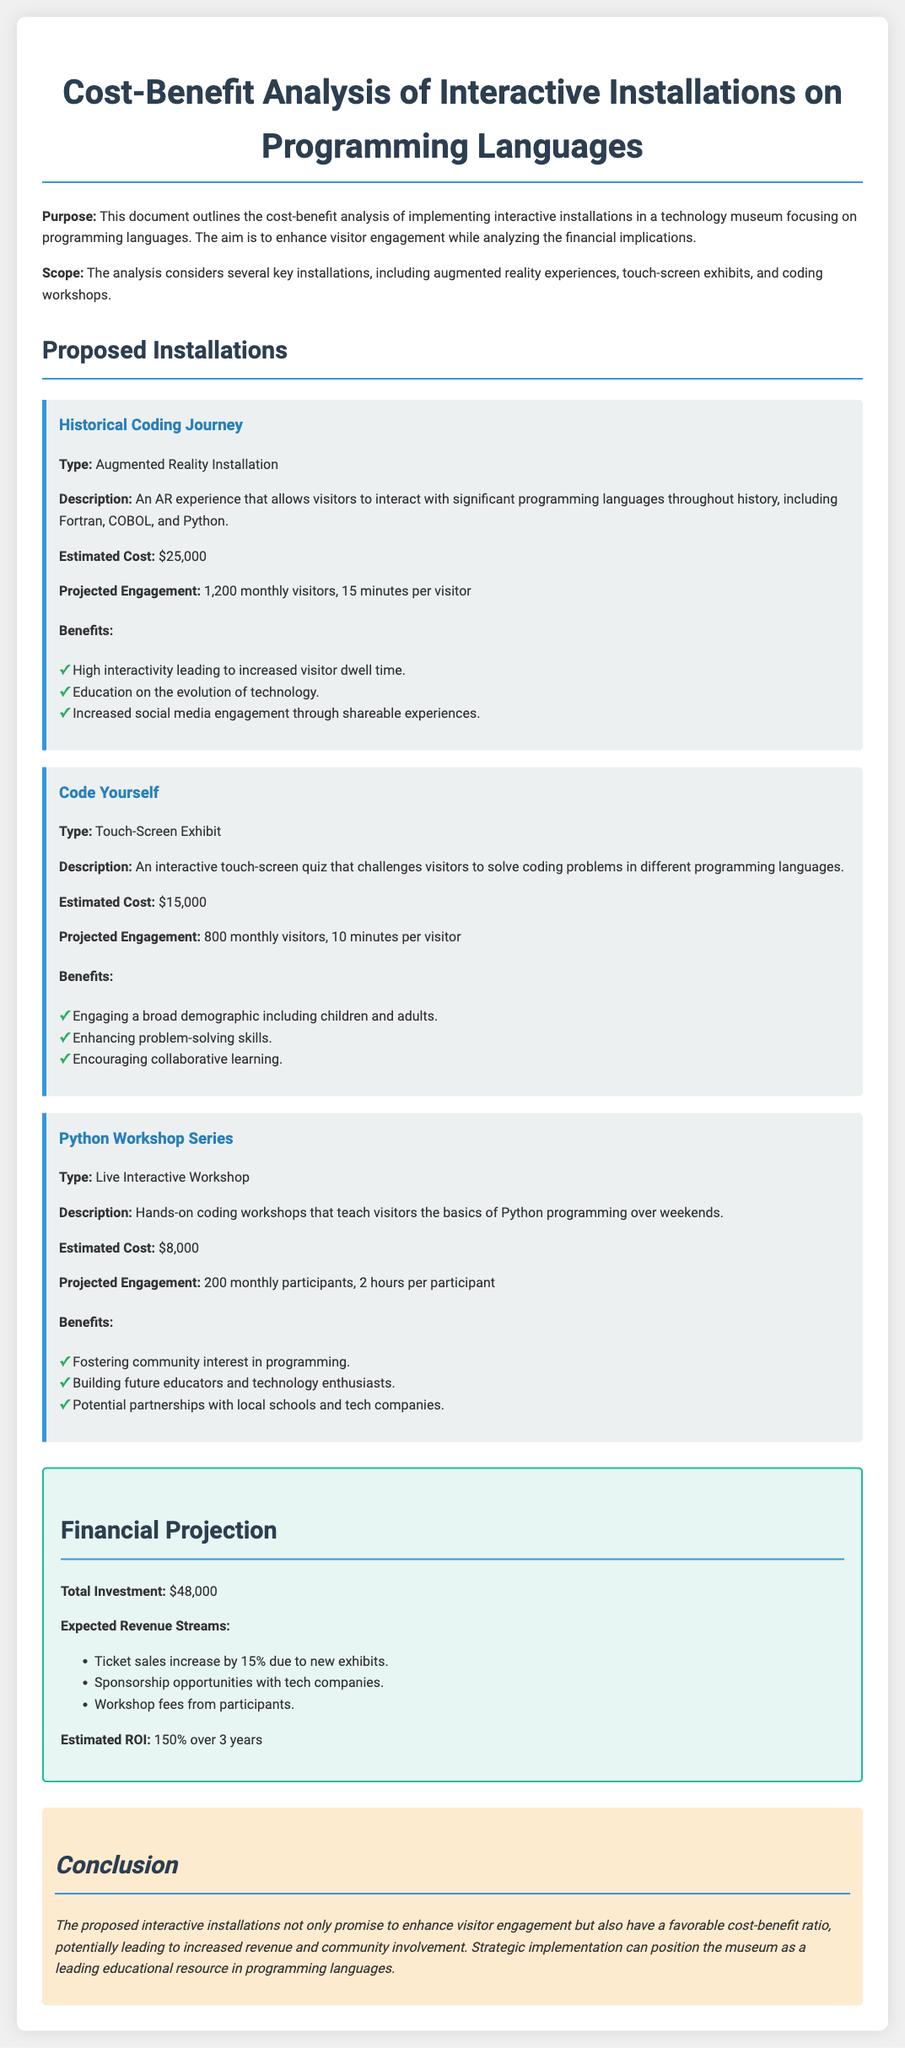What is the estimated cost for the Historical Coding Journey? The estimated cost is explicitly mentioned in the document for this installation.
Answer: $25,000 What type of installation is the Python Workshop Series? The document categorizes the Python Workshop Series under a specific type.
Answer: Live Interactive Workshop How many monthly participants are projected for the Python Workshop Series? The document provides a specific number for projected participants for this workshop.
Answer: 200 monthly participants What is the total investment for the proposed installations? This information is clearly stated in the financial projection section of the document.
Answer: $48,000 What is the estimated ROI over 3 years? The document outlines the return on investment as a percentage over a specific time frame.
Answer: 150% What is one expected revenue stream mentioned in the report? The document lists different expected revenue streams, and this is one example stated.
Answer: Ticket sales increase by 15% Which installation aims to enhance problem-solving skills? The document includes descriptions of installations with specific goals.
Answer: Code Yourself How many minutes per visitor is projected for the Historical Coding Journey? The document specifies the duration of engagement for visitors in this installation.
Answer: 15 minutes What is a benefit of the Python Workshop Series? The document details various benefits related to each installation, and this answer highlights one of them.
Answer: Fostering community interest in programming 